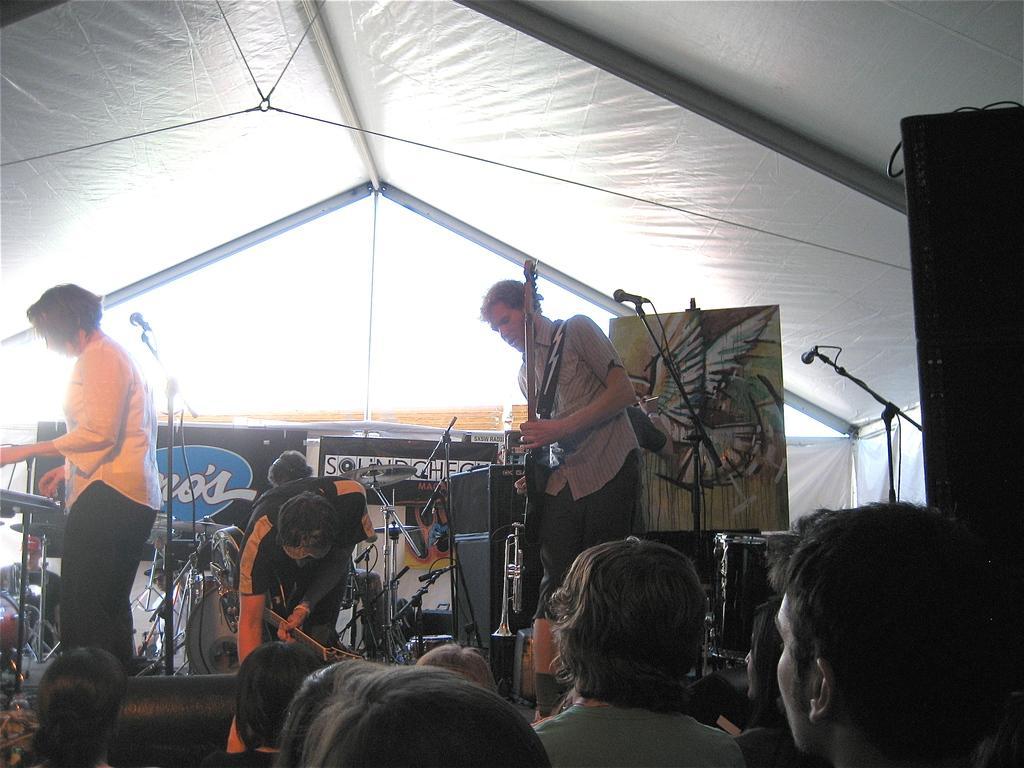Please provide a concise description of this image. In this image i can see there are group of people who are standing on the stage and holding microphone and playing musical instruments 